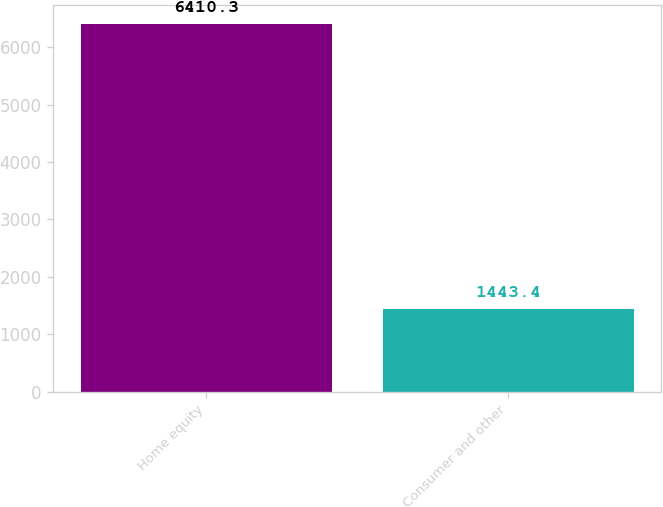Convert chart. <chart><loc_0><loc_0><loc_500><loc_500><bar_chart><fcel>Home equity<fcel>Consumer and other<nl><fcel>6410.3<fcel>1443.4<nl></chart> 